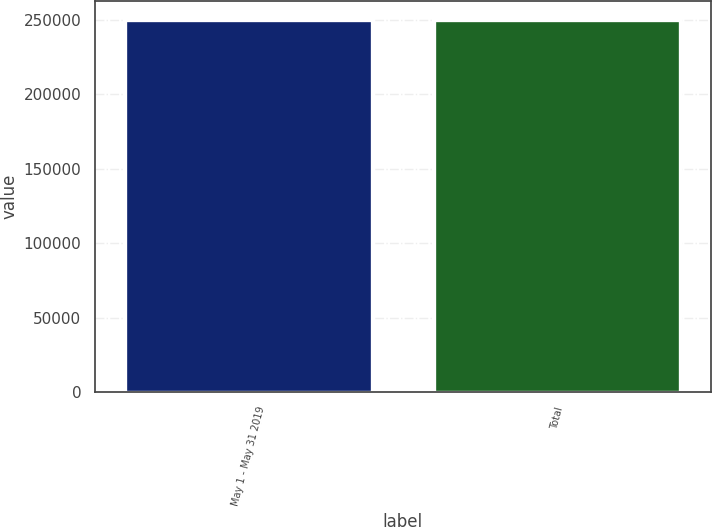Convert chart to OTSL. <chart><loc_0><loc_0><loc_500><loc_500><bar_chart><fcel>May 1 - May 31 2019<fcel>Total<nl><fcel>250000<fcel>250000<nl></chart> 